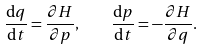Convert formula to latex. <formula><loc_0><loc_0><loc_500><loc_500>\frac { \mathrm d q } { \mathrm d t } = \frac { \partial H } { \partial p } , \quad \frac { \mathrm d p } { \mathrm d t } = - \frac { \partial H } { \partial q } .</formula> 